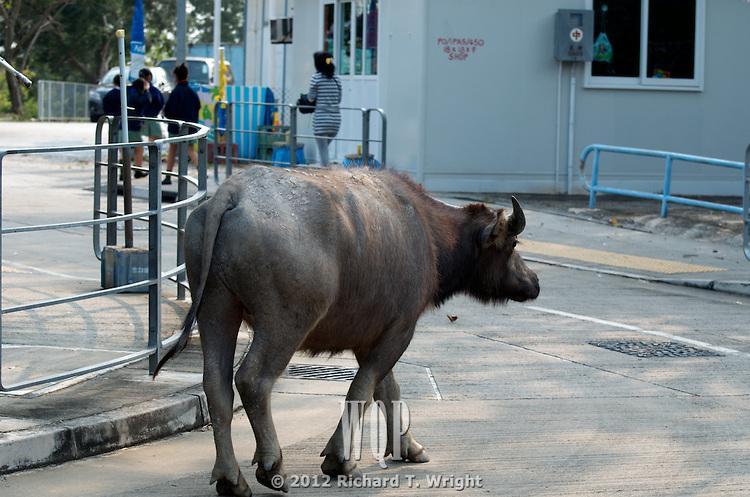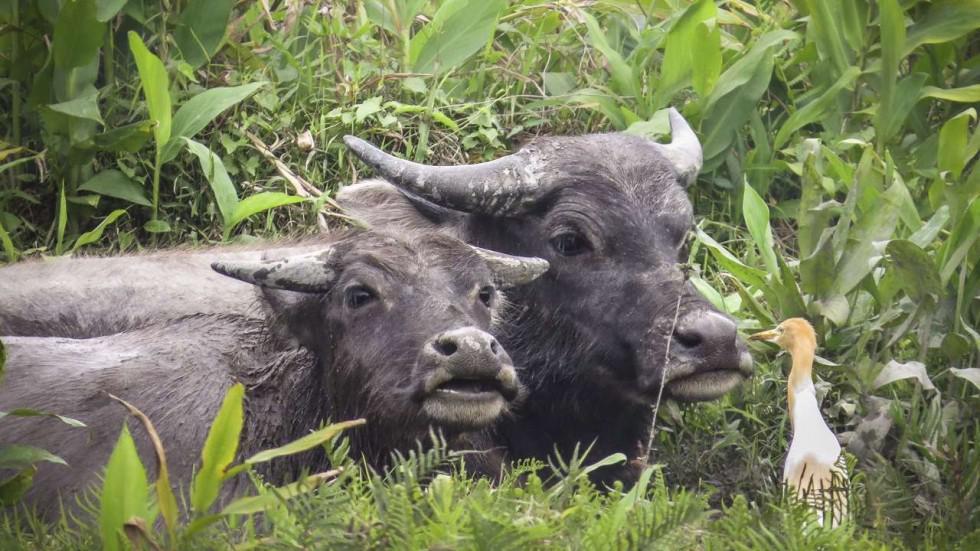The first image is the image on the left, the second image is the image on the right. Assess this claim about the two images: "There are animals but no humans on both pictures.". Correct or not? Answer yes or no. No. 